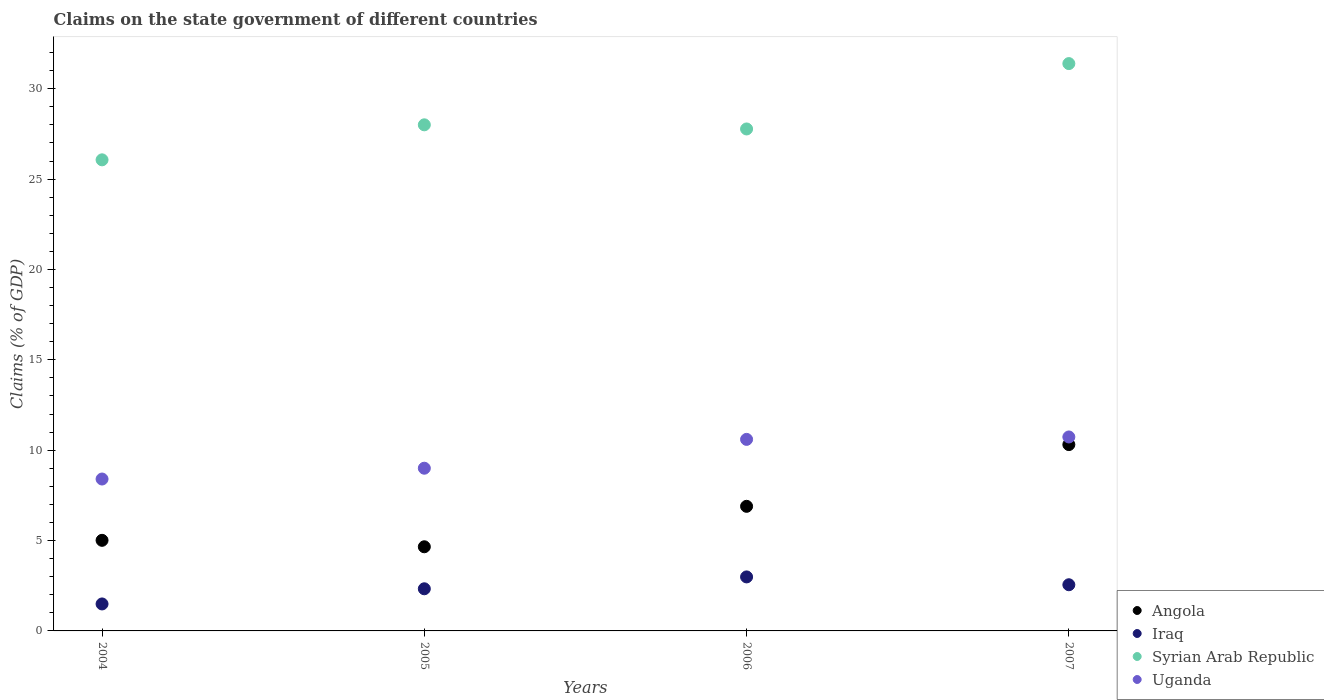What is the percentage of GDP claimed on the state government in Iraq in 2007?
Your answer should be compact. 2.55. Across all years, what is the maximum percentage of GDP claimed on the state government in Uganda?
Make the answer very short. 10.73. Across all years, what is the minimum percentage of GDP claimed on the state government in Angola?
Keep it short and to the point. 4.66. In which year was the percentage of GDP claimed on the state government in Iraq minimum?
Make the answer very short. 2004. What is the total percentage of GDP claimed on the state government in Angola in the graph?
Provide a short and direct response. 26.87. What is the difference between the percentage of GDP claimed on the state government in Uganda in 2004 and that in 2006?
Keep it short and to the point. -2.19. What is the difference between the percentage of GDP claimed on the state government in Iraq in 2006 and the percentage of GDP claimed on the state government in Angola in 2004?
Offer a terse response. -2.02. What is the average percentage of GDP claimed on the state government in Iraq per year?
Offer a very short reply. 2.34. In the year 2007, what is the difference between the percentage of GDP claimed on the state government in Syrian Arab Republic and percentage of GDP claimed on the state government in Angola?
Your answer should be compact. 21.08. What is the ratio of the percentage of GDP claimed on the state government in Uganda in 2004 to that in 2005?
Give a very brief answer. 0.93. Is the difference between the percentage of GDP claimed on the state government in Syrian Arab Republic in 2005 and 2006 greater than the difference between the percentage of GDP claimed on the state government in Angola in 2005 and 2006?
Provide a short and direct response. Yes. What is the difference between the highest and the second highest percentage of GDP claimed on the state government in Iraq?
Keep it short and to the point. 0.43. What is the difference between the highest and the lowest percentage of GDP claimed on the state government in Angola?
Provide a short and direct response. 5.65. Is the sum of the percentage of GDP claimed on the state government in Angola in 2004 and 2006 greater than the maximum percentage of GDP claimed on the state government in Iraq across all years?
Provide a short and direct response. Yes. Does the percentage of GDP claimed on the state government in Uganda monotonically increase over the years?
Provide a short and direct response. Yes. Is the percentage of GDP claimed on the state government in Angola strictly greater than the percentage of GDP claimed on the state government in Uganda over the years?
Give a very brief answer. No. Is the percentage of GDP claimed on the state government in Iraq strictly less than the percentage of GDP claimed on the state government in Uganda over the years?
Give a very brief answer. Yes. How many dotlines are there?
Ensure brevity in your answer.  4. How many years are there in the graph?
Make the answer very short. 4. What is the difference between two consecutive major ticks on the Y-axis?
Your answer should be very brief. 5. Are the values on the major ticks of Y-axis written in scientific E-notation?
Ensure brevity in your answer.  No. Does the graph contain any zero values?
Keep it short and to the point. No. Does the graph contain grids?
Keep it short and to the point. No. How many legend labels are there?
Provide a short and direct response. 4. What is the title of the graph?
Provide a succinct answer. Claims on the state government of different countries. What is the label or title of the X-axis?
Offer a very short reply. Years. What is the label or title of the Y-axis?
Offer a terse response. Claims (% of GDP). What is the Claims (% of GDP) of Angola in 2004?
Make the answer very short. 5.01. What is the Claims (% of GDP) of Iraq in 2004?
Provide a short and direct response. 1.49. What is the Claims (% of GDP) in Syrian Arab Republic in 2004?
Your response must be concise. 26.06. What is the Claims (% of GDP) of Uganda in 2004?
Your answer should be compact. 8.4. What is the Claims (% of GDP) of Angola in 2005?
Give a very brief answer. 4.66. What is the Claims (% of GDP) of Iraq in 2005?
Your answer should be compact. 2.33. What is the Claims (% of GDP) of Syrian Arab Republic in 2005?
Offer a terse response. 28. What is the Claims (% of GDP) in Uganda in 2005?
Offer a terse response. 9. What is the Claims (% of GDP) in Angola in 2006?
Provide a succinct answer. 6.89. What is the Claims (% of GDP) of Iraq in 2006?
Ensure brevity in your answer.  2.99. What is the Claims (% of GDP) of Syrian Arab Republic in 2006?
Give a very brief answer. 27.77. What is the Claims (% of GDP) of Uganda in 2006?
Give a very brief answer. 10.6. What is the Claims (% of GDP) in Angola in 2007?
Make the answer very short. 10.31. What is the Claims (% of GDP) of Iraq in 2007?
Provide a short and direct response. 2.55. What is the Claims (% of GDP) of Syrian Arab Republic in 2007?
Provide a succinct answer. 31.39. What is the Claims (% of GDP) in Uganda in 2007?
Ensure brevity in your answer.  10.73. Across all years, what is the maximum Claims (% of GDP) in Angola?
Offer a terse response. 10.31. Across all years, what is the maximum Claims (% of GDP) of Iraq?
Your answer should be very brief. 2.99. Across all years, what is the maximum Claims (% of GDP) of Syrian Arab Republic?
Keep it short and to the point. 31.39. Across all years, what is the maximum Claims (% of GDP) in Uganda?
Your answer should be compact. 10.73. Across all years, what is the minimum Claims (% of GDP) of Angola?
Give a very brief answer. 4.66. Across all years, what is the minimum Claims (% of GDP) in Iraq?
Offer a very short reply. 1.49. Across all years, what is the minimum Claims (% of GDP) in Syrian Arab Republic?
Provide a short and direct response. 26.06. Across all years, what is the minimum Claims (% of GDP) in Uganda?
Provide a succinct answer. 8.4. What is the total Claims (% of GDP) of Angola in the graph?
Make the answer very short. 26.87. What is the total Claims (% of GDP) in Iraq in the graph?
Give a very brief answer. 9.37. What is the total Claims (% of GDP) in Syrian Arab Republic in the graph?
Offer a very short reply. 113.23. What is the total Claims (% of GDP) of Uganda in the graph?
Your answer should be very brief. 38.74. What is the difference between the Claims (% of GDP) in Angola in 2004 and that in 2005?
Ensure brevity in your answer.  0.36. What is the difference between the Claims (% of GDP) of Iraq in 2004 and that in 2005?
Give a very brief answer. -0.84. What is the difference between the Claims (% of GDP) of Syrian Arab Republic in 2004 and that in 2005?
Provide a succinct answer. -1.94. What is the difference between the Claims (% of GDP) of Uganda in 2004 and that in 2005?
Ensure brevity in your answer.  -0.6. What is the difference between the Claims (% of GDP) of Angola in 2004 and that in 2006?
Make the answer very short. -1.88. What is the difference between the Claims (% of GDP) of Iraq in 2004 and that in 2006?
Make the answer very short. -1.5. What is the difference between the Claims (% of GDP) in Syrian Arab Republic in 2004 and that in 2006?
Give a very brief answer. -1.71. What is the difference between the Claims (% of GDP) of Uganda in 2004 and that in 2006?
Provide a succinct answer. -2.19. What is the difference between the Claims (% of GDP) of Angola in 2004 and that in 2007?
Ensure brevity in your answer.  -5.3. What is the difference between the Claims (% of GDP) in Iraq in 2004 and that in 2007?
Offer a very short reply. -1.06. What is the difference between the Claims (% of GDP) of Syrian Arab Republic in 2004 and that in 2007?
Ensure brevity in your answer.  -5.33. What is the difference between the Claims (% of GDP) of Uganda in 2004 and that in 2007?
Provide a short and direct response. -2.33. What is the difference between the Claims (% of GDP) in Angola in 2005 and that in 2006?
Your answer should be compact. -2.24. What is the difference between the Claims (% of GDP) in Iraq in 2005 and that in 2006?
Provide a succinct answer. -0.66. What is the difference between the Claims (% of GDP) of Syrian Arab Republic in 2005 and that in 2006?
Make the answer very short. 0.23. What is the difference between the Claims (% of GDP) in Uganda in 2005 and that in 2006?
Offer a terse response. -1.6. What is the difference between the Claims (% of GDP) of Angola in 2005 and that in 2007?
Make the answer very short. -5.65. What is the difference between the Claims (% of GDP) in Iraq in 2005 and that in 2007?
Your response must be concise. -0.22. What is the difference between the Claims (% of GDP) in Syrian Arab Republic in 2005 and that in 2007?
Your answer should be compact. -3.39. What is the difference between the Claims (% of GDP) of Uganda in 2005 and that in 2007?
Your answer should be compact. -1.73. What is the difference between the Claims (% of GDP) of Angola in 2006 and that in 2007?
Give a very brief answer. -3.42. What is the difference between the Claims (% of GDP) in Iraq in 2006 and that in 2007?
Keep it short and to the point. 0.43. What is the difference between the Claims (% of GDP) of Syrian Arab Republic in 2006 and that in 2007?
Give a very brief answer. -3.62. What is the difference between the Claims (% of GDP) of Uganda in 2006 and that in 2007?
Your answer should be very brief. -0.13. What is the difference between the Claims (% of GDP) of Angola in 2004 and the Claims (% of GDP) of Iraq in 2005?
Your answer should be compact. 2.68. What is the difference between the Claims (% of GDP) of Angola in 2004 and the Claims (% of GDP) of Syrian Arab Republic in 2005?
Provide a short and direct response. -22.99. What is the difference between the Claims (% of GDP) in Angola in 2004 and the Claims (% of GDP) in Uganda in 2005?
Provide a short and direct response. -3.99. What is the difference between the Claims (% of GDP) of Iraq in 2004 and the Claims (% of GDP) of Syrian Arab Republic in 2005?
Your answer should be compact. -26.51. What is the difference between the Claims (% of GDP) in Iraq in 2004 and the Claims (% of GDP) in Uganda in 2005?
Your response must be concise. -7.51. What is the difference between the Claims (% of GDP) of Syrian Arab Republic in 2004 and the Claims (% of GDP) of Uganda in 2005?
Ensure brevity in your answer.  17.06. What is the difference between the Claims (% of GDP) in Angola in 2004 and the Claims (% of GDP) in Iraq in 2006?
Provide a succinct answer. 2.02. What is the difference between the Claims (% of GDP) in Angola in 2004 and the Claims (% of GDP) in Syrian Arab Republic in 2006?
Your answer should be very brief. -22.76. What is the difference between the Claims (% of GDP) of Angola in 2004 and the Claims (% of GDP) of Uganda in 2006?
Ensure brevity in your answer.  -5.59. What is the difference between the Claims (% of GDP) of Iraq in 2004 and the Claims (% of GDP) of Syrian Arab Republic in 2006?
Your response must be concise. -26.28. What is the difference between the Claims (% of GDP) of Iraq in 2004 and the Claims (% of GDP) of Uganda in 2006?
Your answer should be very brief. -9.11. What is the difference between the Claims (% of GDP) in Syrian Arab Republic in 2004 and the Claims (% of GDP) in Uganda in 2006?
Your response must be concise. 15.47. What is the difference between the Claims (% of GDP) in Angola in 2004 and the Claims (% of GDP) in Iraq in 2007?
Your answer should be very brief. 2.46. What is the difference between the Claims (% of GDP) of Angola in 2004 and the Claims (% of GDP) of Syrian Arab Republic in 2007?
Provide a succinct answer. -26.38. What is the difference between the Claims (% of GDP) in Angola in 2004 and the Claims (% of GDP) in Uganda in 2007?
Keep it short and to the point. -5.72. What is the difference between the Claims (% of GDP) of Iraq in 2004 and the Claims (% of GDP) of Syrian Arab Republic in 2007?
Give a very brief answer. -29.9. What is the difference between the Claims (% of GDP) of Iraq in 2004 and the Claims (% of GDP) of Uganda in 2007?
Your answer should be compact. -9.24. What is the difference between the Claims (% of GDP) in Syrian Arab Republic in 2004 and the Claims (% of GDP) in Uganda in 2007?
Your answer should be very brief. 15.33. What is the difference between the Claims (% of GDP) in Angola in 2005 and the Claims (% of GDP) in Iraq in 2006?
Make the answer very short. 1.67. What is the difference between the Claims (% of GDP) in Angola in 2005 and the Claims (% of GDP) in Syrian Arab Republic in 2006?
Offer a very short reply. -23.12. What is the difference between the Claims (% of GDP) in Angola in 2005 and the Claims (% of GDP) in Uganda in 2006?
Ensure brevity in your answer.  -5.94. What is the difference between the Claims (% of GDP) of Iraq in 2005 and the Claims (% of GDP) of Syrian Arab Republic in 2006?
Give a very brief answer. -25.44. What is the difference between the Claims (% of GDP) in Iraq in 2005 and the Claims (% of GDP) in Uganda in 2006?
Provide a succinct answer. -8.27. What is the difference between the Claims (% of GDP) in Syrian Arab Republic in 2005 and the Claims (% of GDP) in Uganda in 2006?
Your response must be concise. 17.4. What is the difference between the Claims (% of GDP) in Angola in 2005 and the Claims (% of GDP) in Iraq in 2007?
Provide a short and direct response. 2.1. What is the difference between the Claims (% of GDP) in Angola in 2005 and the Claims (% of GDP) in Syrian Arab Republic in 2007?
Make the answer very short. -26.73. What is the difference between the Claims (% of GDP) of Angola in 2005 and the Claims (% of GDP) of Uganda in 2007?
Offer a terse response. -6.08. What is the difference between the Claims (% of GDP) in Iraq in 2005 and the Claims (% of GDP) in Syrian Arab Republic in 2007?
Your answer should be compact. -29.06. What is the difference between the Claims (% of GDP) in Syrian Arab Republic in 2005 and the Claims (% of GDP) in Uganda in 2007?
Your answer should be very brief. 17.27. What is the difference between the Claims (% of GDP) in Angola in 2006 and the Claims (% of GDP) in Iraq in 2007?
Offer a terse response. 4.34. What is the difference between the Claims (% of GDP) in Angola in 2006 and the Claims (% of GDP) in Syrian Arab Republic in 2007?
Give a very brief answer. -24.5. What is the difference between the Claims (% of GDP) in Angola in 2006 and the Claims (% of GDP) in Uganda in 2007?
Your answer should be compact. -3.84. What is the difference between the Claims (% of GDP) of Iraq in 2006 and the Claims (% of GDP) of Syrian Arab Republic in 2007?
Offer a very short reply. -28.4. What is the difference between the Claims (% of GDP) of Iraq in 2006 and the Claims (% of GDP) of Uganda in 2007?
Provide a short and direct response. -7.74. What is the difference between the Claims (% of GDP) in Syrian Arab Republic in 2006 and the Claims (% of GDP) in Uganda in 2007?
Provide a succinct answer. 17.04. What is the average Claims (% of GDP) in Angola per year?
Your response must be concise. 6.72. What is the average Claims (% of GDP) of Iraq per year?
Make the answer very short. 2.34. What is the average Claims (% of GDP) in Syrian Arab Republic per year?
Offer a terse response. 28.31. What is the average Claims (% of GDP) in Uganda per year?
Keep it short and to the point. 9.68. In the year 2004, what is the difference between the Claims (% of GDP) of Angola and Claims (% of GDP) of Iraq?
Provide a succinct answer. 3.52. In the year 2004, what is the difference between the Claims (% of GDP) in Angola and Claims (% of GDP) in Syrian Arab Republic?
Keep it short and to the point. -21.05. In the year 2004, what is the difference between the Claims (% of GDP) of Angola and Claims (% of GDP) of Uganda?
Give a very brief answer. -3.39. In the year 2004, what is the difference between the Claims (% of GDP) of Iraq and Claims (% of GDP) of Syrian Arab Republic?
Offer a very short reply. -24.57. In the year 2004, what is the difference between the Claims (% of GDP) of Iraq and Claims (% of GDP) of Uganda?
Provide a short and direct response. -6.91. In the year 2004, what is the difference between the Claims (% of GDP) of Syrian Arab Republic and Claims (% of GDP) of Uganda?
Provide a succinct answer. 17.66. In the year 2005, what is the difference between the Claims (% of GDP) of Angola and Claims (% of GDP) of Iraq?
Provide a succinct answer. 2.32. In the year 2005, what is the difference between the Claims (% of GDP) in Angola and Claims (% of GDP) in Syrian Arab Republic?
Your answer should be compact. -23.35. In the year 2005, what is the difference between the Claims (% of GDP) in Angola and Claims (% of GDP) in Uganda?
Provide a short and direct response. -4.35. In the year 2005, what is the difference between the Claims (% of GDP) of Iraq and Claims (% of GDP) of Syrian Arab Republic?
Your answer should be very brief. -25.67. In the year 2005, what is the difference between the Claims (% of GDP) of Iraq and Claims (% of GDP) of Uganda?
Keep it short and to the point. -6.67. In the year 2005, what is the difference between the Claims (% of GDP) of Syrian Arab Republic and Claims (% of GDP) of Uganda?
Your response must be concise. 19. In the year 2006, what is the difference between the Claims (% of GDP) in Angola and Claims (% of GDP) in Iraq?
Give a very brief answer. 3.91. In the year 2006, what is the difference between the Claims (% of GDP) in Angola and Claims (% of GDP) in Syrian Arab Republic?
Ensure brevity in your answer.  -20.88. In the year 2006, what is the difference between the Claims (% of GDP) of Angola and Claims (% of GDP) of Uganda?
Your answer should be compact. -3.7. In the year 2006, what is the difference between the Claims (% of GDP) of Iraq and Claims (% of GDP) of Syrian Arab Republic?
Give a very brief answer. -24.79. In the year 2006, what is the difference between the Claims (% of GDP) of Iraq and Claims (% of GDP) of Uganda?
Provide a succinct answer. -7.61. In the year 2006, what is the difference between the Claims (% of GDP) of Syrian Arab Republic and Claims (% of GDP) of Uganda?
Your response must be concise. 17.18. In the year 2007, what is the difference between the Claims (% of GDP) of Angola and Claims (% of GDP) of Iraq?
Offer a terse response. 7.76. In the year 2007, what is the difference between the Claims (% of GDP) in Angola and Claims (% of GDP) in Syrian Arab Republic?
Provide a short and direct response. -21.08. In the year 2007, what is the difference between the Claims (% of GDP) of Angola and Claims (% of GDP) of Uganda?
Give a very brief answer. -0.42. In the year 2007, what is the difference between the Claims (% of GDP) in Iraq and Claims (% of GDP) in Syrian Arab Republic?
Ensure brevity in your answer.  -28.83. In the year 2007, what is the difference between the Claims (% of GDP) in Iraq and Claims (% of GDP) in Uganda?
Offer a very short reply. -8.18. In the year 2007, what is the difference between the Claims (% of GDP) of Syrian Arab Republic and Claims (% of GDP) of Uganda?
Provide a succinct answer. 20.66. What is the ratio of the Claims (% of GDP) in Angola in 2004 to that in 2005?
Your response must be concise. 1.08. What is the ratio of the Claims (% of GDP) of Iraq in 2004 to that in 2005?
Your answer should be very brief. 0.64. What is the ratio of the Claims (% of GDP) in Syrian Arab Republic in 2004 to that in 2005?
Ensure brevity in your answer.  0.93. What is the ratio of the Claims (% of GDP) in Uganda in 2004 to that in 2005?
Ensure brevity in your answer.  0.93. What is the ratio of the Claims (% of GDP) of Angola in 2004 to that in 2006?
Make the answer very short. 0.73. What is the ratio of the Claims (% of GDP) in Iraq in 2004 to that in 2006?
Ensure brevity in your answer.  0.5. What is the ratio of the Claims (% of GDP) in Syrian Arab Republic in 2004 to that in 2006?
Provide a short and direct response. 0.94. What is the ratio of the Claims (% of GDP) of Uganda in 2004 to that in 2006?
Keep it short and to the point. 0.79. What is the ratio of the Claims (% of GDP) in Angola in 2004 to that in 2007?
Your answer should be compact. 0.49. What is the ratio of the Claims (% of GDP) in Iraq in 2004 to that in 2007?
Your response must be concise. 0.58. What is the ratio of the Claims (% of GDP) in Syrian Arab Republic in 2004 to that in 2007?
Your answer should be very brief. 0.83. What is the ratio of the Claims (% of GDP) in Uganda in 2004 to that in 2007?
Your answer should be very brief. 0.78. What is the ratio of the Claims (% of GDP) of Angola in 2005 to that in 2006?
Make the answer very short. 0.68. What is the ratio of the Claims (% of GDP) of Iraq in 2005 to that in 2006?
Your answer should be compact. 0.78. What is the ratio of the Claims (% of GDP) in Syrian Arab Republic in 2005 to that in 2006?
Offer a terse response. 1.01. What is the ratio of the Claims (% of GDP) of Uganda in 2005 to that in 2006?
Give a very brief answer. 0.85. What is the ratio of the Claims (% of GDP) in Angola in 2005 to that in 2007?
Provide a short and direct response. 0.45. What is the ratio of the Claims (% of GDP) of Iraq in 2005 to that in 2007?
Make the answer very short. 0.91. What is the ratio of the Claims (% of GDP) of Syrian Arab Republic in 2005 to that in 2007?
Your answer should be very brief. 0.89. What is the ratio of the Claims (% of GDP) in Uganda in 2005 to that in 2007?
Your answer should be compact. 0.84. What is the ratio of the Claims (% of GDP) in Angola in 2006 to that in 2007?
Your response must be concise. 0.67. What is the ratio of the Claims (% of GDP) of Iraq in 2006 to that in 2007?
Offer a very short reply. 1.17. What is the ratio of the Claims (% of GDP) in Syrian Arab Republic in 2006 to that in 2007?
Give a very brief answer. 0.88. What is the ratio of the Claims (% of GDP) in Uganda in 2006 to that in 2007?
Offer a terse response. 0.99. What is the difference between the highest and the second highest Claims (% of GDP) of Angola?
Offer a terse response. 3.42. What is the difference between the highest and the second highest Claims (% of GDP) in Iraq?
Keep it short and to the point. 0.43. What is the difference between the highest and the second highest Claims (% of GDP) of Syrian Arab Republic?
Provide a short and direct response. 3.39. What is the difference between the highest and the second highest Claims (% of GDP) of Uganda?
Provide a short and direct response. 0.13. What is the difference between the highest and the lowest Claims (% of GDP) in Angola?
Ensure brevity in your answer.  5.65. What is the difference between the highest and the lowest Claims (% of GDP) of Iraq?
Make the answer very short. 1.5. What is the difference between the highest and the lowest Claims (% of GDP) in Syrian Arab Republic?
Give a very brief answer. 5.33. What is the difference between the highest and the lowest Claims (% of GDP) of Uganda?
Offer a very short reply. 2.33. 